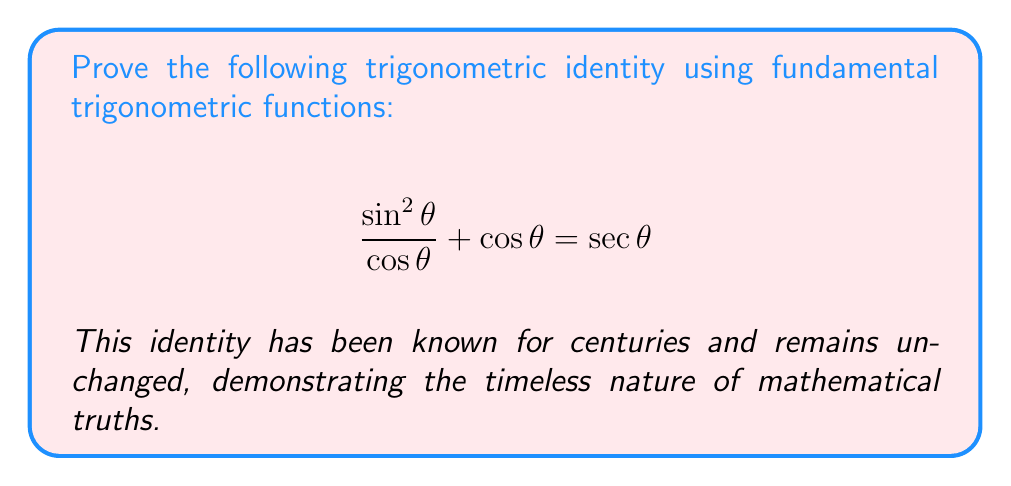What is the answer to this math problem? Let's approach this proof step-by-step using fundamental trigonometric identities:

1) First, recall the fundamental identity: $\sin^2 \theta + \cos^2 \theta = 1$

2) Divide both sides by $\cos^2 \theta$:
   $$\frac{\sin^2 \theta}{\cos^2 \theta} + \frac{\cos^2 \theta}{\cos^2 \theta} = \frac{1}{\cos^2 \theta}$$

3) Simplify:
   $$\tan^2 \theta + 1 = \sec^2 \theta$$

4) This is a well-known identity. Now, let's focus on the left side of our original equation:
   $$\frac{\sin^2 \theta}{\cos \theta} + \cos \theta$$

5) Multiply the first term by $\frac{\cos \theta}{\cos \theta}$ (which equals 1):
   $$\frac{\sin^2 \theta}{\cos \theta} \cdot \frac{\cos \theta}{\cos \theta} + \cos \theta = \frac{\sin^2 \theta}{\cos^2 \theta} \cdot \cos \theta + \cos \theta$$

6) Simplify:
   $$\tan^2 \theta \cdot \cos \theta + \cos \theta = \cos \theta(\tan^2 \theta + 1)$$

7) From step 3, we know that $\tan^2 \theta + 1 = \sec^2 \theta$, so:
   $$\cos \theta(\tan^2 \theta + 1) = \cos \theta \cdot \sec^2 \theta$$

8) Recall that $\sec \theta = \frac{1}{\cos \theta}$, so $\sec^2 \theta = \frac{1}{\cos^2 \theta}$

9) Therefore:
   $$\cos \theta \cdot \sec^2 \theta = \cos \theta \cdot \frac{1}{\cos^2 \theta} = \frac{1}{\cos \theta} = \sec \theta$$

Thus, we have proven that $\frac{\sin^2 \theta}{\cos \theta} + \cos \theta = \sec \theta$.
Answer: $$\frac{\sin^2 \theta}{\cos \theta} + \cos \theta = \sec \theta$$ 